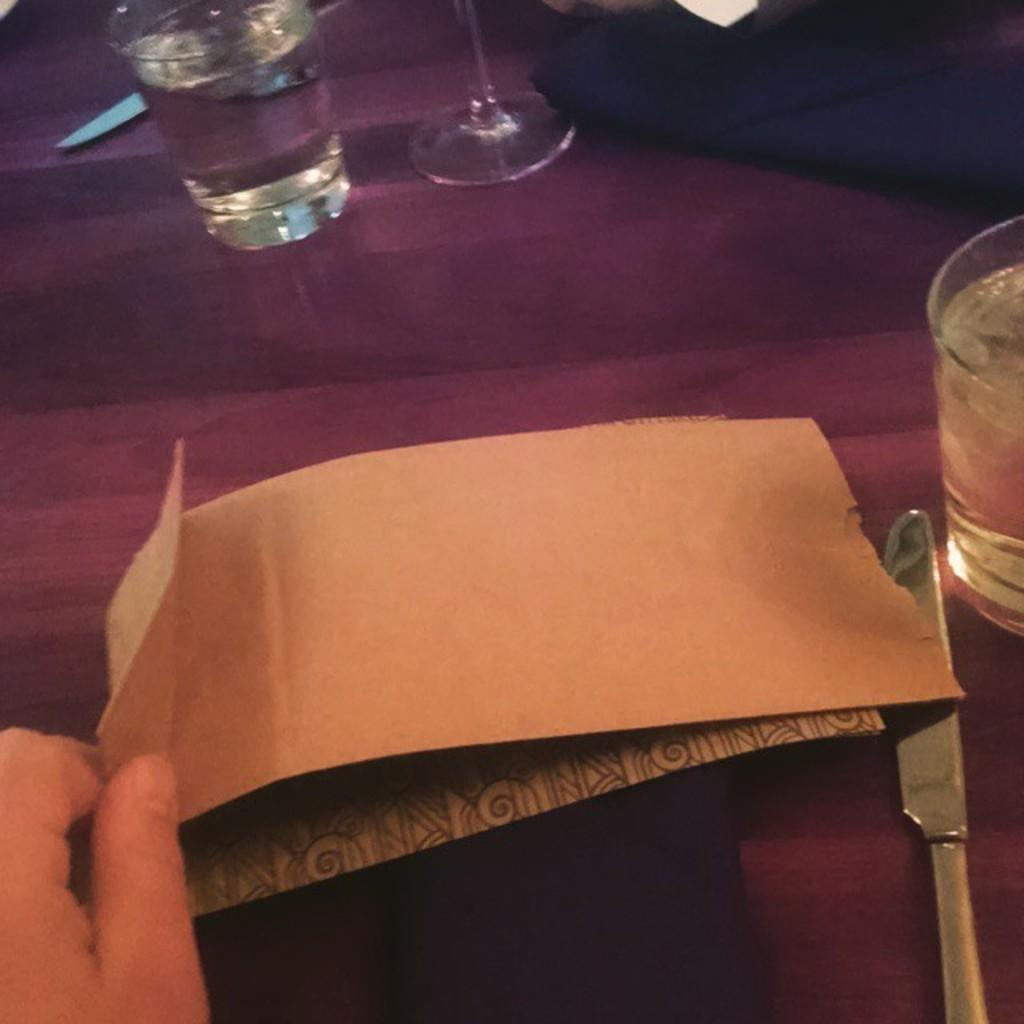What type of glass can be seen in the image? There is a wine glass in the image. What piece of furniture is present in the image? There is a table in the image. What is covering the table? There is cloth on the table. What utensils are on the table? There are knives on the table. What else is on the table besides the knives? There is paper on the table. What type of pipe is visible in the image? There is no pipe present in the image. What scent can be detected in the image? The image does not provide any information about scents. 